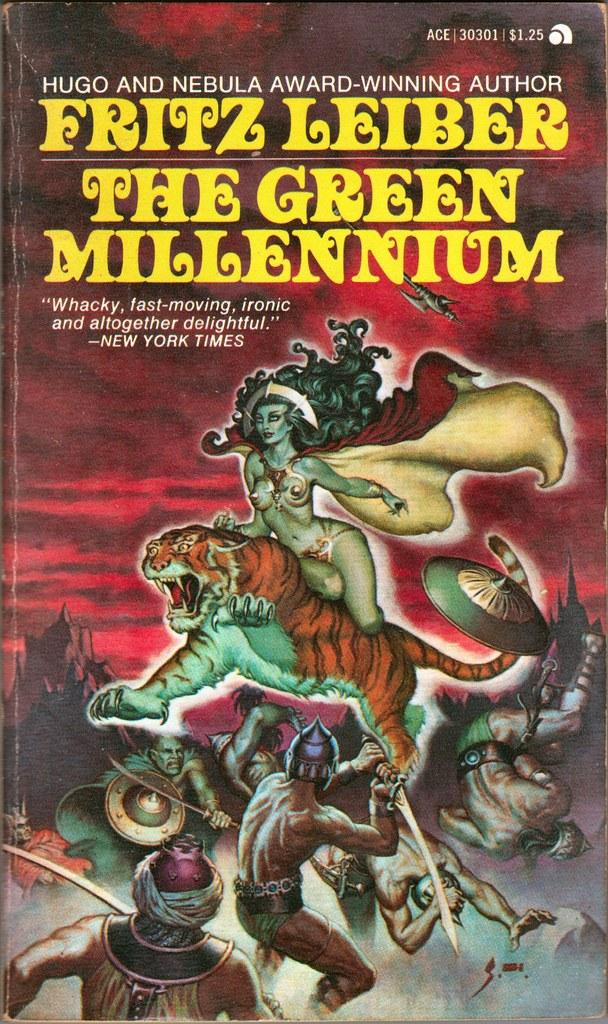<image>
Relay a brief, clear account of the picture shown. An award winning author wrote The Green Millennium. 